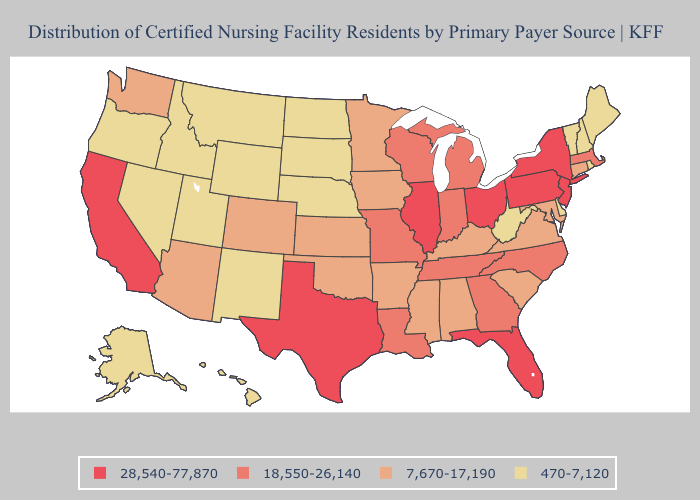Among the states that border Tennessee , which have the highest value?
Keep it brief. Georgia, Missouri, North Carolina. Does New Hampshire have a higher value than Michigan?
Answer briefly. No. Does the first symbol in the legend represent the smallest category?
Concise answer only. No. What is the highest value in the USA?
Concise answer only. 28,540-77,870. What is the highest value in the USA?
Concise answer only. 28,540-77,870. Name the states that have a value in the range 18,550-26,140?
Quick response, please. Georgia, Indiana, Louisiana, Massachusetts, Michigan, Missouri, North Carolina, Tennessee, Wisconsin. Is the legend a continuous bar?
Concise answer only. No. Which states have the lowest value in the Northeast?
Give a very brief answer. Maine, New Hampshire, Rhode Island, Vermont. What is the lowest value in states that border Georgia?
Keep it brief. 7,670-17,190. Which states have the highest value in the USA?
Short answer required. California, Florida, Illinois, New Jersey, New York, Ohio, Pennsylvania, Texas. What is the highest value in states that border Florida?
Give a very brief answer. 18,550-26,140. Does California have the highest value in the West?
Quick response, please. Yes. What is the value of Oklahoma?
Short answer required. 7,670-17,190. What is the value of New Hampshire?
Quick response, please. 470-7,120. What is the value of Maryland?
Short answer required. 7,670-17,190. 